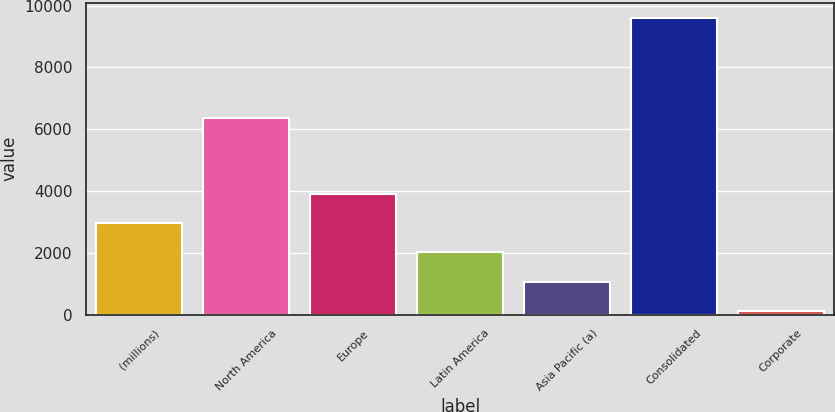<chart> <loc_0><loc_0><loc_500><loc_500><bar_chart><fcel>(millions)<fcel>North America<fcel>Europe<fcel>Latin America<fcel>Asia Pacific (a)<fcel>Consolidated<fcel>Corporate<nl><fcel>2965.72<fcel>6369.3<fcel>3915.46<fcel>2015.98<fcel>1066.24<fcel>9613.9<fcel>116.5<nl></chart> 